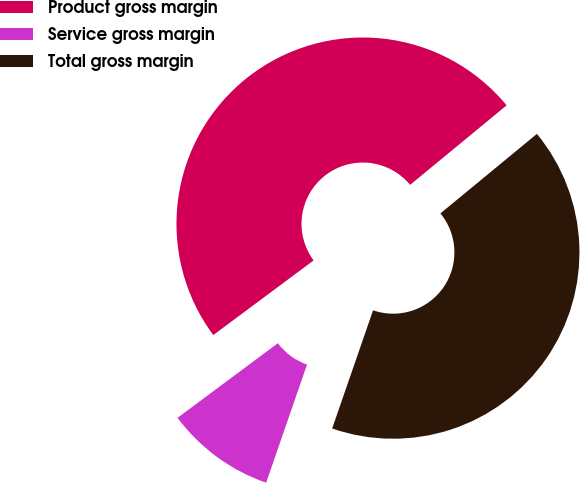Convert chart. <chart><loc_0><loc_0><loc_500><loc_500><pie_chart><fcel>Product gross margin<fcel>Service gross margin<fcel>Total gross margin<nl><fcel>49.21%<fcel>9.52%<fcel>41.27%<nl></chart> 